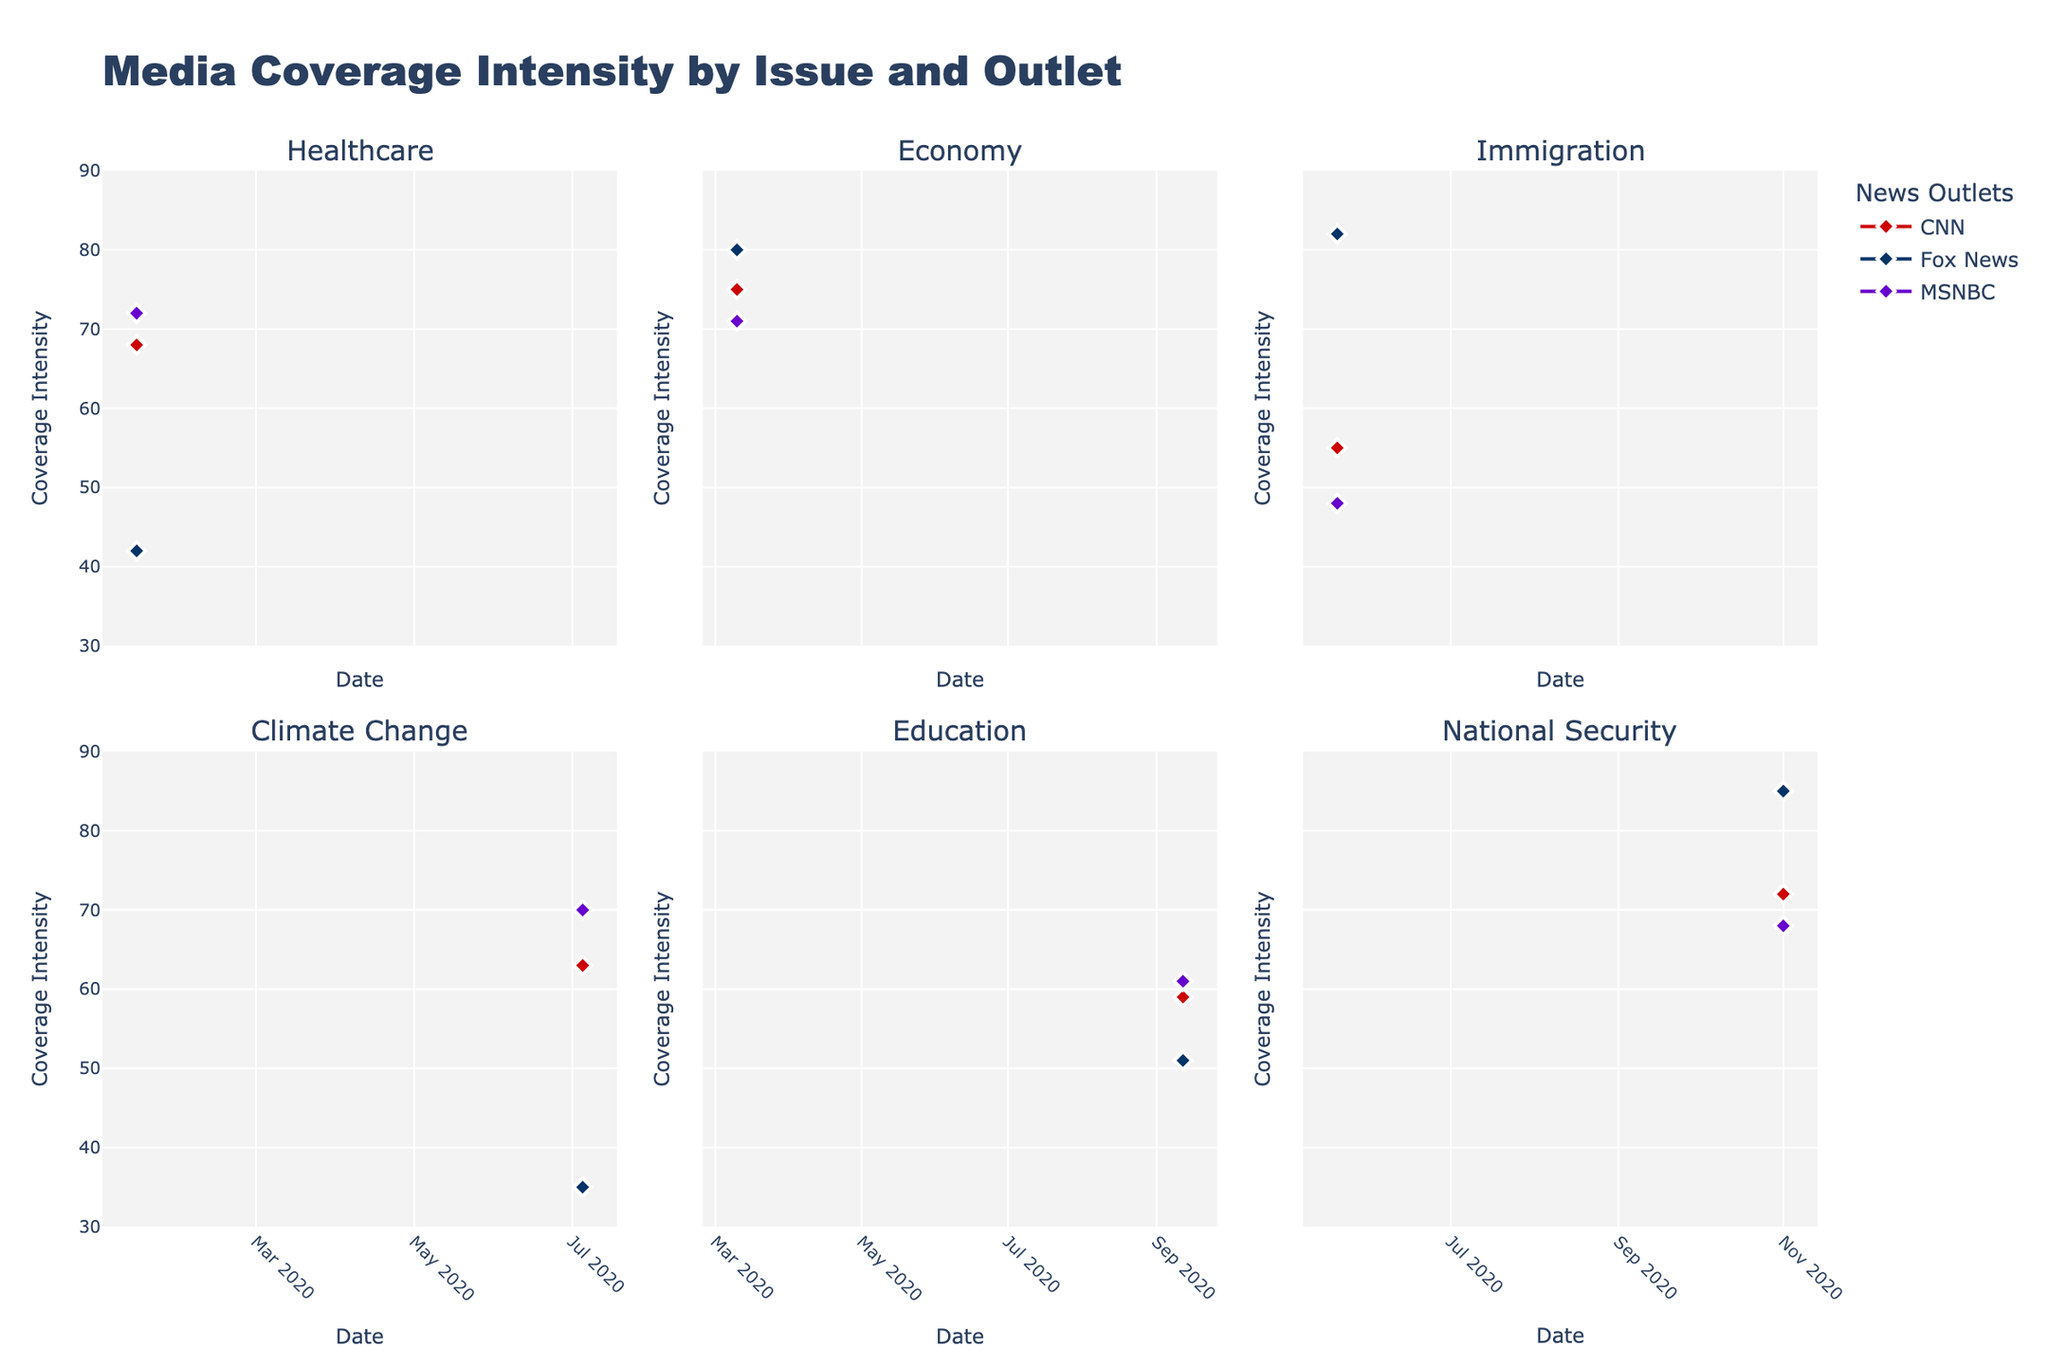How many political issues are covered in total? There are six subplots in the figure, each representing a different political issue.
Answer: 6 Which news outlet has the highest coverage intensity for the issue of Immigration on the given date? For Immigration, Fox News has the highest coverage intensity, which can be observed by comparing the marker heights for CNN, Fox News, and MSNBC.
Answer: Fox News What is the average coverage intensity for CNN across all issues? First, find the coverage intensities for CNN across all issues: 68 (Healthcare), 75 (Economy), 55 (Immigration), 63 (Climate Change), 59 (Education), and 72 (National Security). Sum these values: 68 + 75 + 55 + 63 + 59 + 72 = 392. Divide by the number of issues (6): 392 / 6 = 65.33.
Answer: 65.33 Which political issue shows the greatest variation in coverage intensity among the three outlets? Compare the range of coverage intensities for each issue. For Healthcare: 72 - 42 = 30, for Economy: 80 - 71 = 9, for Immigration: 82 - 48 = 34, for Climate Change: 70 - 35 = 35, for Education: 61 - 51 = 10, for National Security: 85 - 68 = 17. Climate Change shows the greatest variation of 35.
Answer: Climate Change On which date does Fox News have the lowest coverage intensity, and what is that value? Looking at Fox News' plot, the lowest coverage intensity can be observed for Climate Change on 2020-07-05, which is 35.
Answer: 2020-07-05, 35 Do CNN and MSNBC ever have the same coverage intensity for any political issue? By examining the overlap of coverage intensity markers for CNN and MSNBC, we see that only for Education on 2020-09-12, both have a coverage intensity of 61.
Answer: Yes, for Education on 2020-09-12 What is the total coverage intensity of MSNBC for Healthcare and National Security combined? For Healthcare, MSNBC has a coverage intensity of 72. For National Security, it has 68. Adding these values: 72 + 68 = 140.
Answer: 140 Which news outlet has the most consistent coverage intensity across different political issues? Comparing the ranges for each outlet across the issues: CNN ranges from 55 to 75 (difference of 20), Fox News ranges from 35 to 85 (difference of 50), and MSNBC ranges from 48 to 72 (difference of 24). CNN has the smallest range, indicating the most consistency.
Answer: CNN 